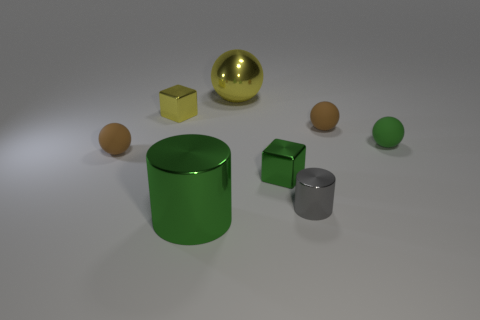Subtract all yellow balls. How many balls are left? 3 Subtract all tiny green spheres. How many spheres are left? 3 Subtract 1 spheres. How many spheres are left? 3 Subtract all cyan balls. Subtract all green cylinders. How many balls are left? 4 Add 1 tiny gray matte cylinders. How many objects exist? 9 Subtract all blocks. How many objects are left? 6 Subtract all tiny gray matte spheres. Subtract all metallic cubes. How many objects are left? 6 Add 4 big metallic cylinders. How many big metallic cylinders are left? 5 Add 6 big green things. How many big green things exist? 7 Subtract 0 cyan cylinders. How many objects are left? 8 